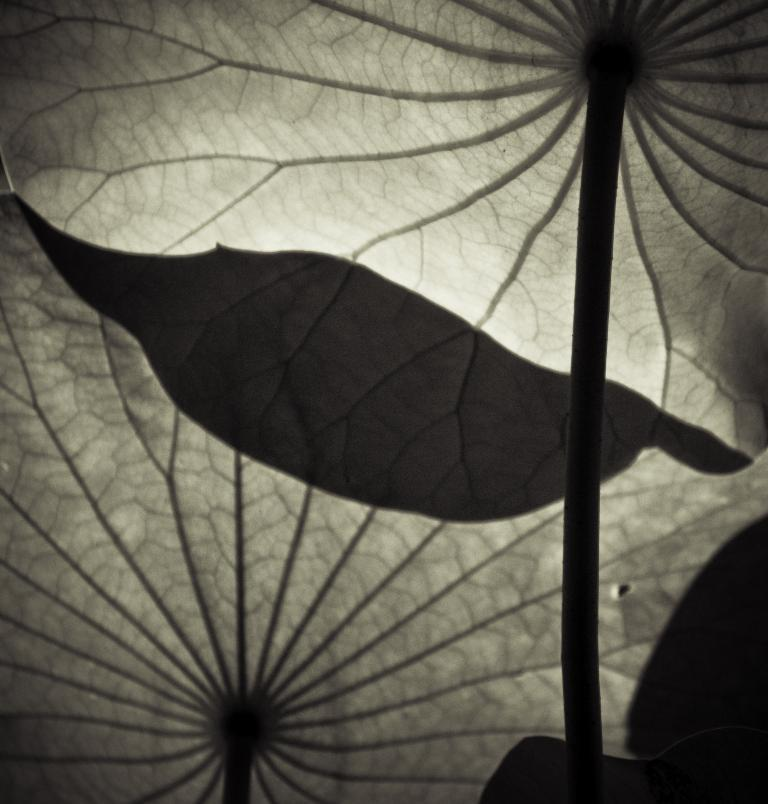What is present in the image? There is a plant in the image. Can you describe the plant's appearance? The plant has leaves on its stems. What type of music is the plant playing in the image? There is no music or indication of music in the image; it only features a plant with leaves on its stems. 